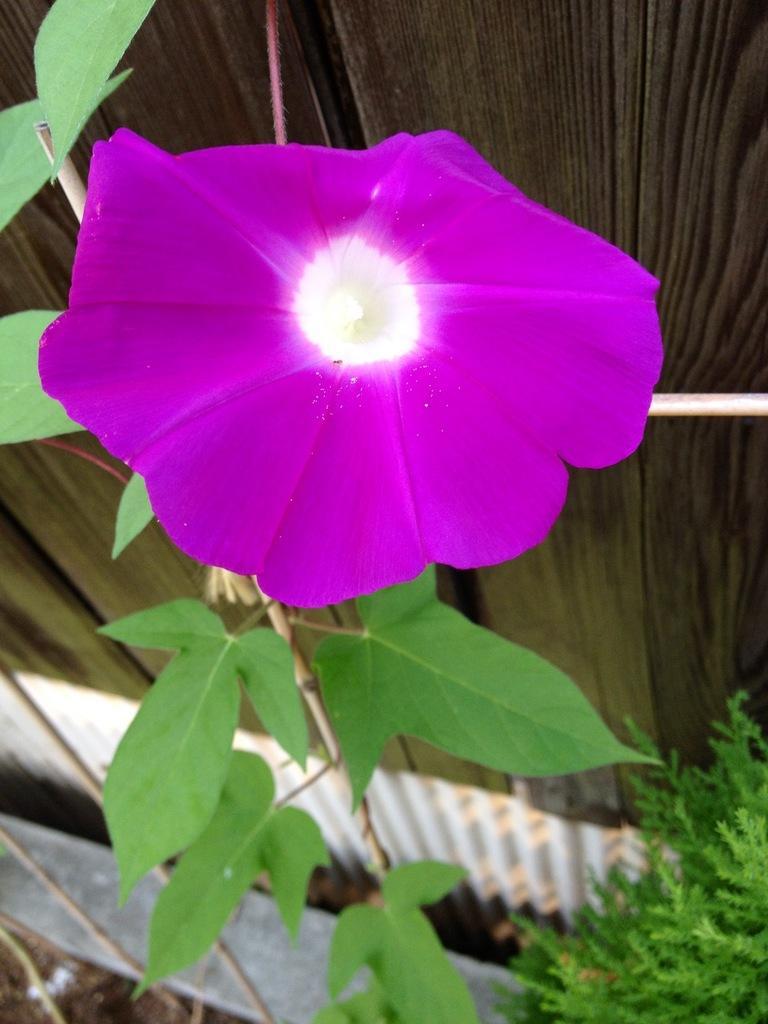Please provide a concise description of this image. In the center of the image we can see a flower, which is in purple color. At the bottom there are plants and leaves. In the background there is a fence. 